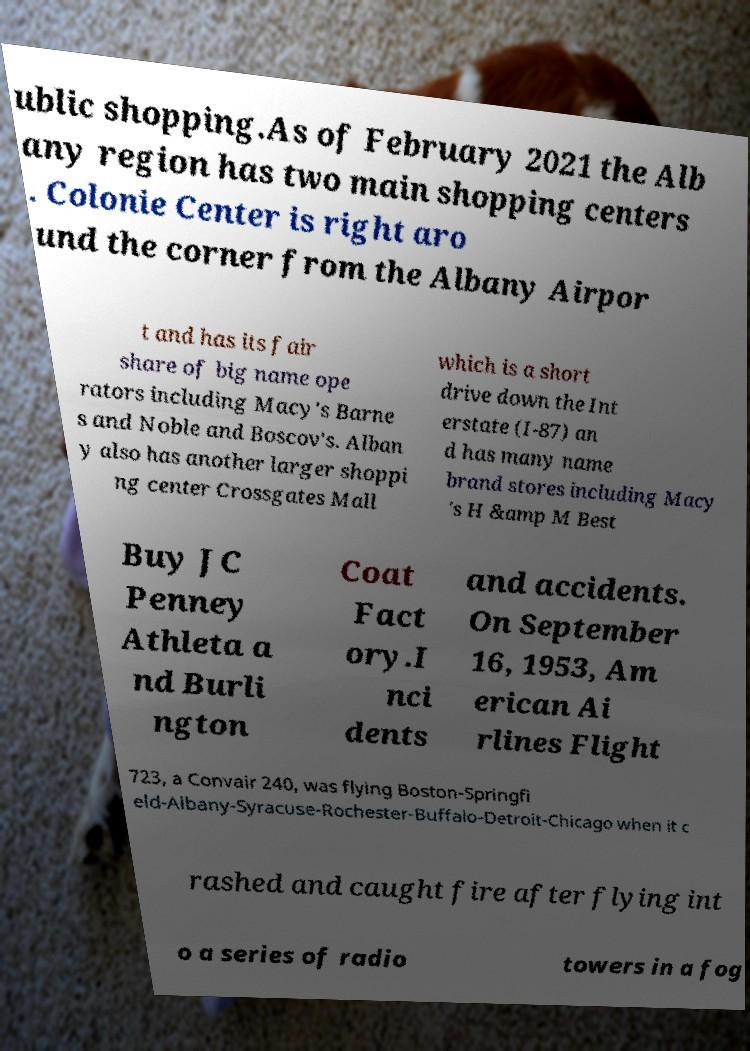Can you read and provide the text displayed in the image?This photo seems to have some interesting text. Can you extract and type it out for me? ublic shopping.As of February 2021 the Alb any region has two main shopping centers . Colonie Center is right aro und the corner from the Albany Airpor t and has its fair share of big name ope rators including Macy's Barne s and Noble and Boscov's. Alban y also has another larger shoppi ng center Crossgates Mall which is a short drive down the Int erstate (I-87) an d has many name brand stores including Macy 's H &amp M Best Buy JC Penney Athleta a nd Burli ngton Coat Fact ory.I nci dents and accidents. On September 16, 1953, Am erican Ai rlines Flight 723, a Convair 240, was flying Boston-Springfi eld-Albany-Syracuse-Rochester-Buffalo-Detroit-Chicago when it c rashed and caught fire after flying int o a series of radio towers in a fog 